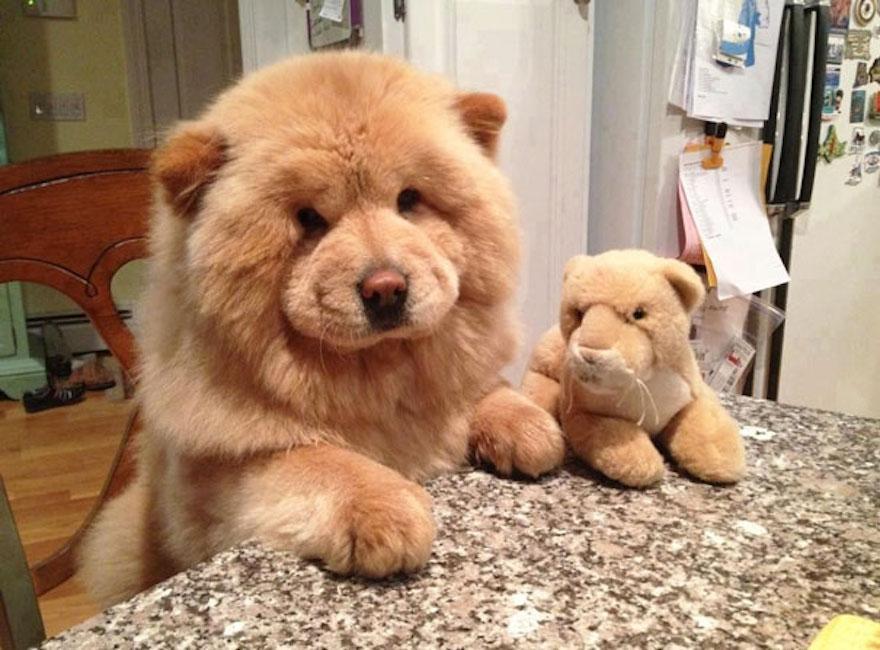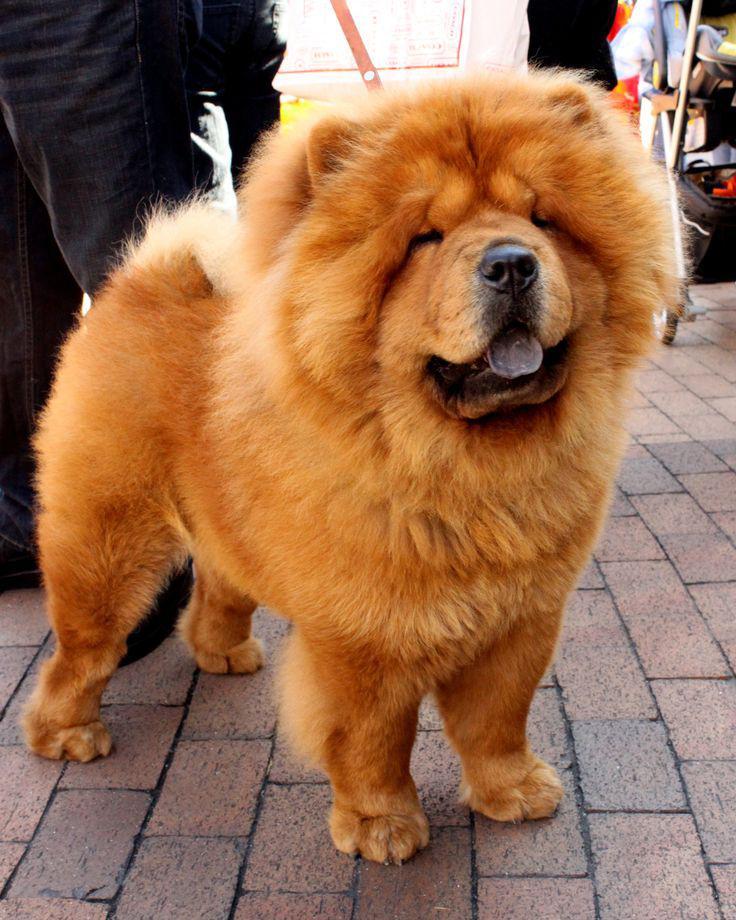The first image is the image on the left, the second image is the image on the right. Examine the images to the left and right. Is the description "There are exactly three dogs in total." accurate? Answer yes or no. No. The first image is the image on the left, the second image is the image on the right. For the images displayed, is the sentence "There are exactly 3 dogs, and two of them are puppies." factually correct? Answer yes or no. No. 